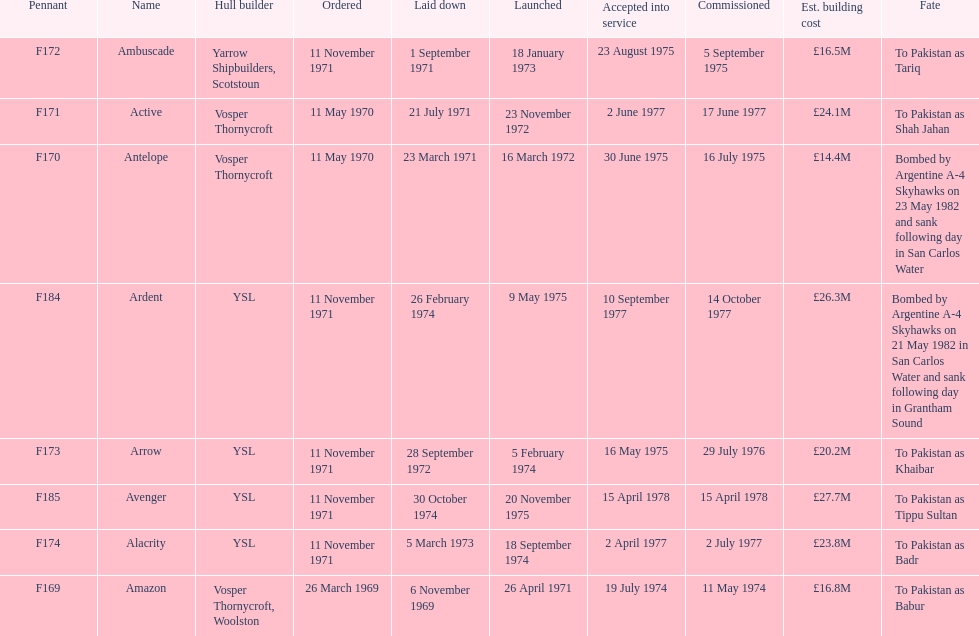Which ship had the highest estimated cost to build? Avenger. 